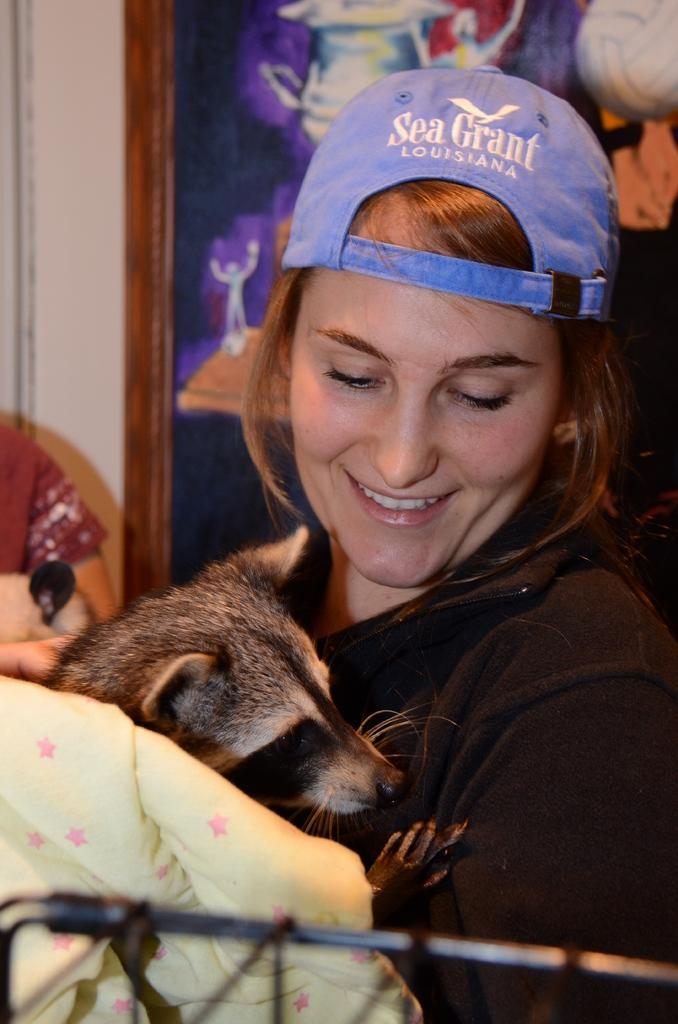Who is present in the image? There is a woman in the image. What is the woman wearing on her head? The woman is wearing a blue hat. What is the woman holding in the image? The woman is holding an animal. What type of jam is the woman spreading on the wound in the image? There is no jam or wound present in the image. The woman is holding an animal, but there is no indication of any jam or wound. 